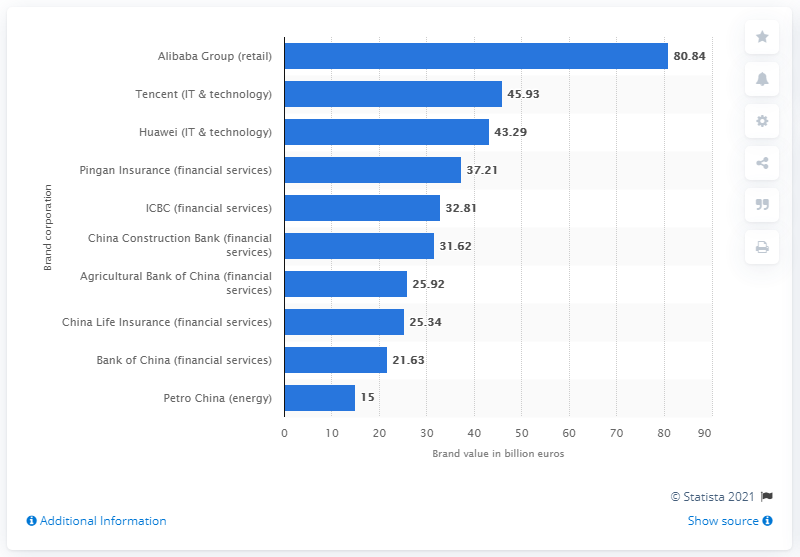Draw attention to some important aspects in this diagram. Alibaba Group's brand value in 2020 was estimated to be 80.84. 